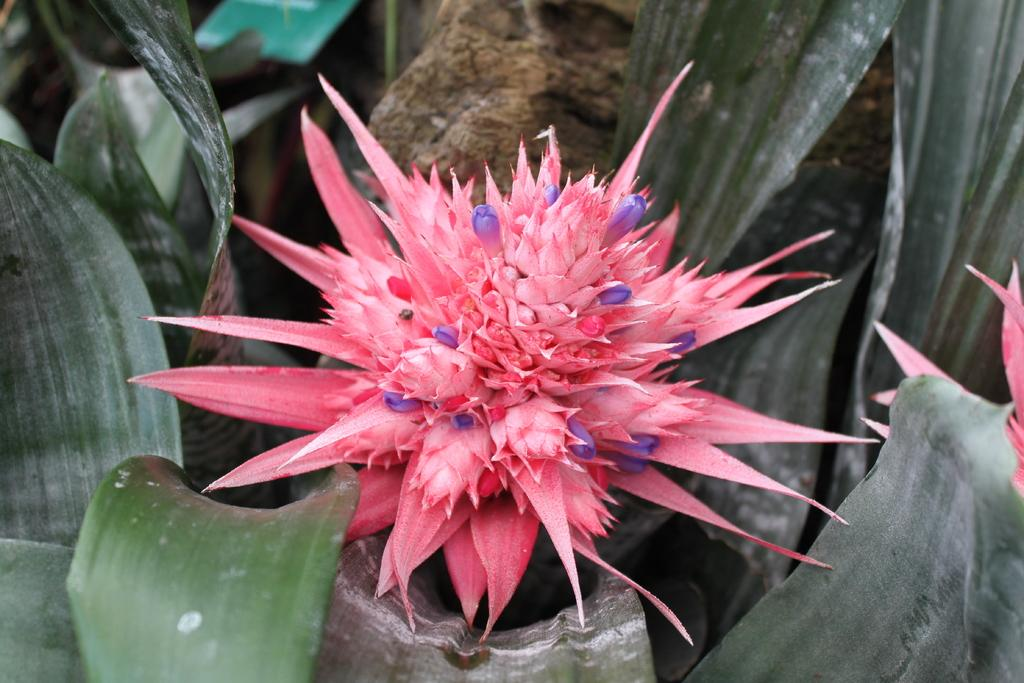What is the main subject in the center of the image? There is a flower in the center of the image. What else can be seen in the image besides the flower? There are leaves in the image. What is the name of the cat in the image? There is no cat present in the image; it features a flower and leaves. 